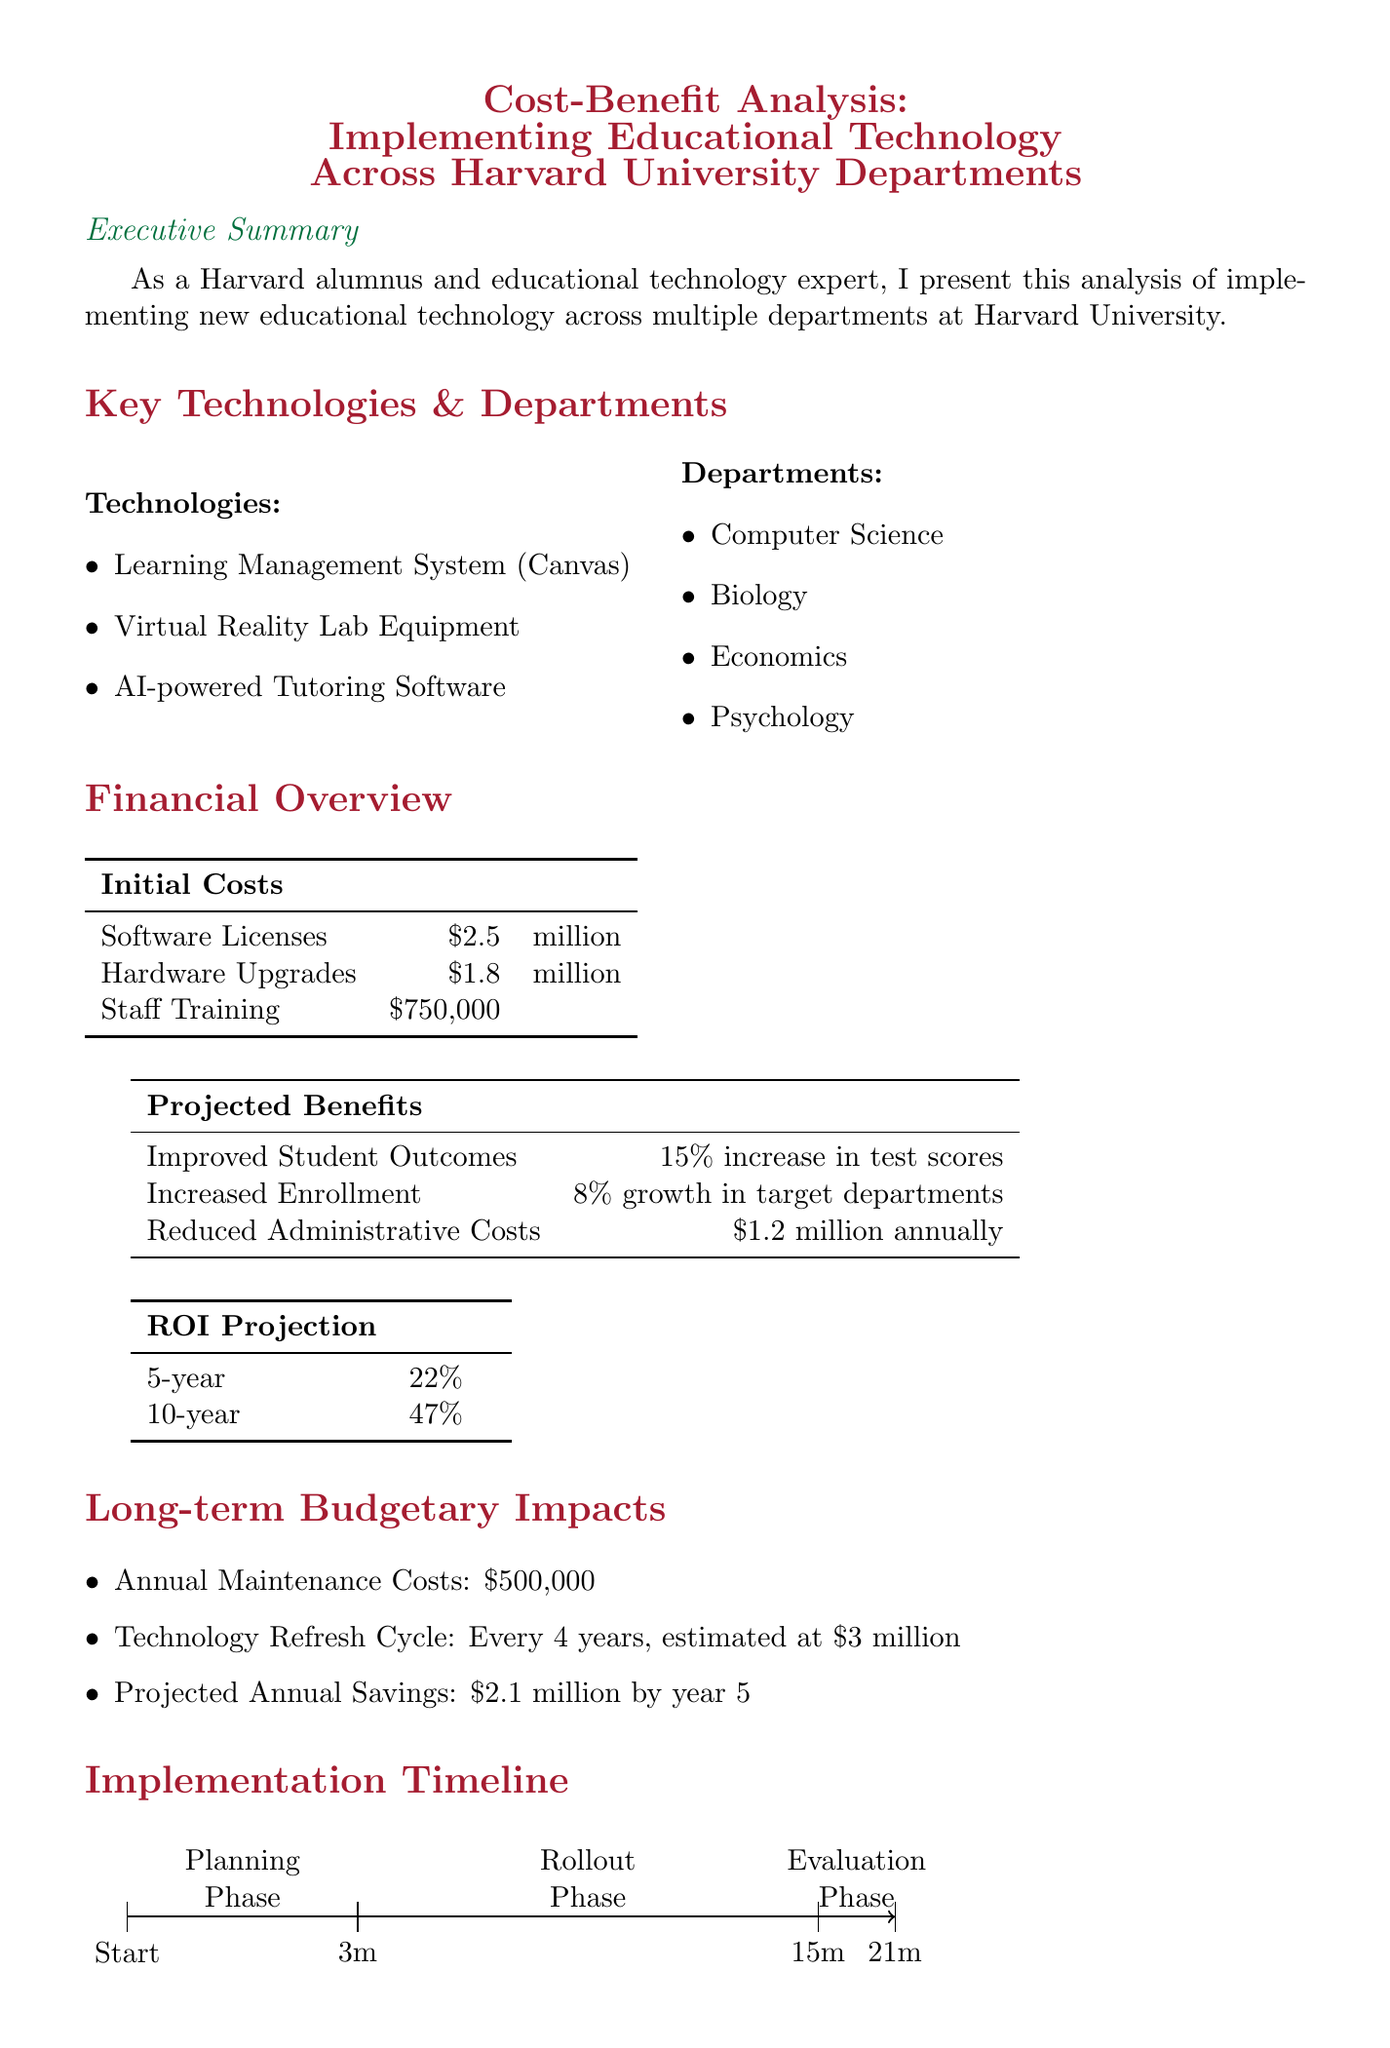What is the total initial cost? The total initial cost is the sum of software licenses, hardware upgrades, and staff training, which is $2.5 million + $1.8 million + $750,000 = $5.05 million.
Answer: $5.05 million What is the projected increase in enrollment? The projected increase in enrollment as stated in the document is 8% growth in target departments.
Answer: 8% What is the expected annual maintenance cost? The expected annual maintenance cost listed in the document is $500,000.
Answer: $500,000 What is the technology refresh cycle? The technology refresh cycle is specified as every 4 years, estimated at $3 million.
Answer: Every 4 years What are the risk factors mentioned? The risk factors include faculty resistance, integration challenges, and potential data security concerns.
Answer: Faculty resistance to new technology, integration challenges with existing systems, potential data security concerns What is the ROI projected after 10 years? The ROI projected after 10 years is stated to be 47%.
Answer: 47% What is the implementation evaluation phase duration? The duration of the evaluation phase following implementation is stated as 6 months.
Answer: 6 months What is the projected annual savings by year 5? The projected annual savings by year 5 is stated to be $2.1 million.
Answer: $2.1 million What are the departments involved in the implementation? The departments involved are Computer Science, Biology, Economics, and Psychology.
Answer: Computer Science, Biology, Economics, Psychology 